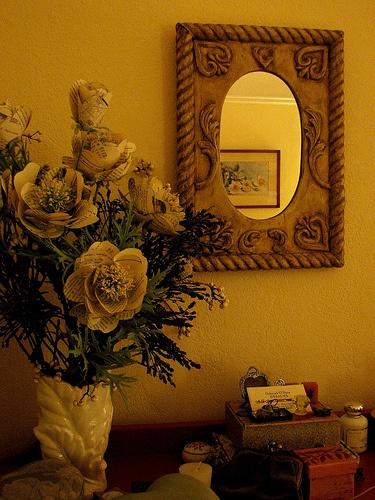Describe the objects in this image and their specific colors. I can see potted plant in olive, black, and maroon tones and vase in olive, maroon, and black tones in this image. 